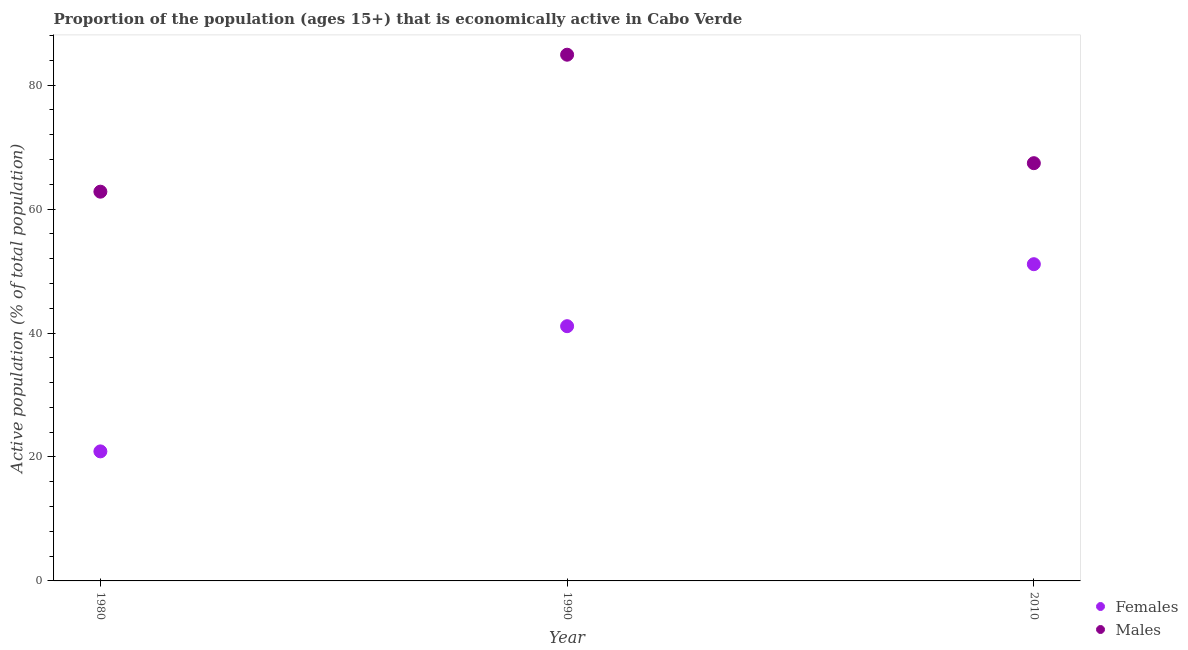What is the percentage of economically active male population in 1980?
Your answer should be compact. 62.8. Across all years, what is the maximum percentage of economically active female population?
Give a very brief answer. 51.1. Across all years, what is the minimum percentage of economically active female population?
Give a very brief answer. 20.9. What is the total percentage of economically active female population in the graph?
Keep it short and to the point. 113.1. What is the difference between the percentage of economically active female population in 1980 and the percentage of economically active male population in 2010?
Your answer should be compact. -46.5. What is the average percentage of economically active female population per year?
Your response must be concise. 37.7. In the year 1990, what is the difference between the percentage of economically active male population and percentage of economically active female population?
Give a very brief answer. 43.8. What is the ratio of the percentage of economically active male population in 1980 to that in 1990?
Your answer should be very brief. 0.74. Is the percentage of economically active female population in 1990 less than that in 2010?
Offer a terse response. Yes. What is the difference between the highest and the lowest percentage of economically active female population?
Offer a very short reply. 30.2. In how many years, is the percentage of economically active female population greater than the average percentage of economically active female population taken over all years?
Keep it short and to the point. 2. How many years are there in the graph?
Your answer should be compact. 3. Are the values on the major ticks of Y-axis written in scientific E-notation?
Keep it short and to the point. No. Does the graph contain any zero values?
Your answer should be compact. No. How are the legend labels stacked?
Provide a short and direct response. Vertical. What is the title of the graph?
Your answer should be very brief. Proportion of the population (ages 15+) that is economically active in Cabo Verde. Does "Chemicals" appear as one of the legend labels in the graph?
Your answer should be very brief. No. What is the label or title of the X-axis?
Your response must be concise. Year. What is the label or title of the Y-axis?
Your response must be concise. Active population (% of total population). What is the Active population (% of total population) in Females in 1980?
Your response must be concise. 20.9. What is the Active population (% of total population) in Males in 1980?
Provide a succinct answer. 62.8. What is the Active population (% of total population) in Females in 1990?
Make the answer very short. 41.1. What is the Active population (% of total population) in Males in 1990?
Provide a succinct answer. 84.9. What is the Active population (% of total population) in Females in 2010?
Offer a very short reply. 51.1. What is the Active population (% of total population) of Males in 2010?
Offer a very short reply. 67.4. Across all years, what is the maximum Active population (% of total population) in Females?
Keep it short and to the point. 51.1. Across all years, what is the maximum Active population (% of total population) in Males?
Your response must be concise. 84.9. Across all years, what is the minimum Active population (% of total population) in Females?
Ensure brevity in your answer.  20.9. Across all years, what is the minimum Active population (% of total population) in Males?
Provide a succinct answer. 62.8. What is the total Active population (% of total population) in Females in the graph?
Your answer should be very brief. 113.1. What is the total Active population (% of total population) in Males in the graph?
Provide a succinct answer. 215.1. What is the difference between the Active population (% of total population) in Females in 1980 and that in 1990?
Your answer should be compact. -20.2. What is the difference between the Active population (% of total population) in Males in 1980 and that in 1990?
Ensure brevity in your answer.  -22.1. What is the difference between the Active population (% of total population) of Females in 1980 and that in 2010?
Give a very brief answer. -30.2. What is the difference between the Active population (% of total population) in Males in 1980 and that in 2010?
Keep it short and to the point. -4.6. What is the difference between the Active population (% of total population) in Females in 1990 and that in 2010?
Your answer should be compact. -10. What is the difference between the Active population (% of total population) in Males in 1990 and that in 2010?
Ensure brevity in your answer.  17.5. What is the difference between the Active population (% of total population) of Females in 1980 and the Active population (% of total population) of Males in 1990?
Provide a short and direct response. -64. What is the difference between the Active population (% of total population) in Females in 1980 and the Active population (% of total population) in Males in 2010?
Provide a succinct answer. -46.5. What is the difference between the Active population (% of total population) of Females in 1990 and the Active population (% of total population) of Males in 2010?
Make the answer very short. -26.3. What is the average Active population (% of total population) in Females per year?
Your response must be concise. 37.7. What is the average Active population (% of total population) of Males per year?
Provide a succinct answer. 71.7. In the year 1980, what is the difference between the Active population (% of total population) of Females and Active population (% of total population) of Males?
Ensure brevity in your answer.  -41.9. In the year 1990, what is the difference between the Active population (% of total population) in Females and Active population (% of total population) in Males?
Provide a short and direct response. -43.8. In the year 2010, what is the difference between the Active population (% of total population) of Females and Active population (% of total population) of Males?
Keep it short and to the point. -16.3. What is the ratio of the Active population (% of total population) of Females in 1980 to that in 1990?
Provide a succinct answer. 0.51. What is the ratio of the Active population (% of total population) in Males in 1980 to that in 1990?
Your response must be concise. 0.74. What is the ratio of the Active population (% of total population) of Females in 1980 to that in 2010?
Your answer should be compact. 0.41. What is the ratio of the Active population (% of total population) of Males in 1980 to that in 2010?
Your response must be concise. 0.93. What is the ratio of the Active population (% of total population) in Females in 1990 to that in 2010?
Offer a very short reply. 0.8. What is the ratio of the Active population (% of total population) in Males in 1990 to that in 2010?
Keep it short and to the point. 1.26. What is the difference between the highest and the lowest Active population (% of total population) of Females?
Offer a terse response. 30.2. What is the difference between the highest and the lowest Active population (% of total population) in Males?
Offer a terse response. 22.1. 